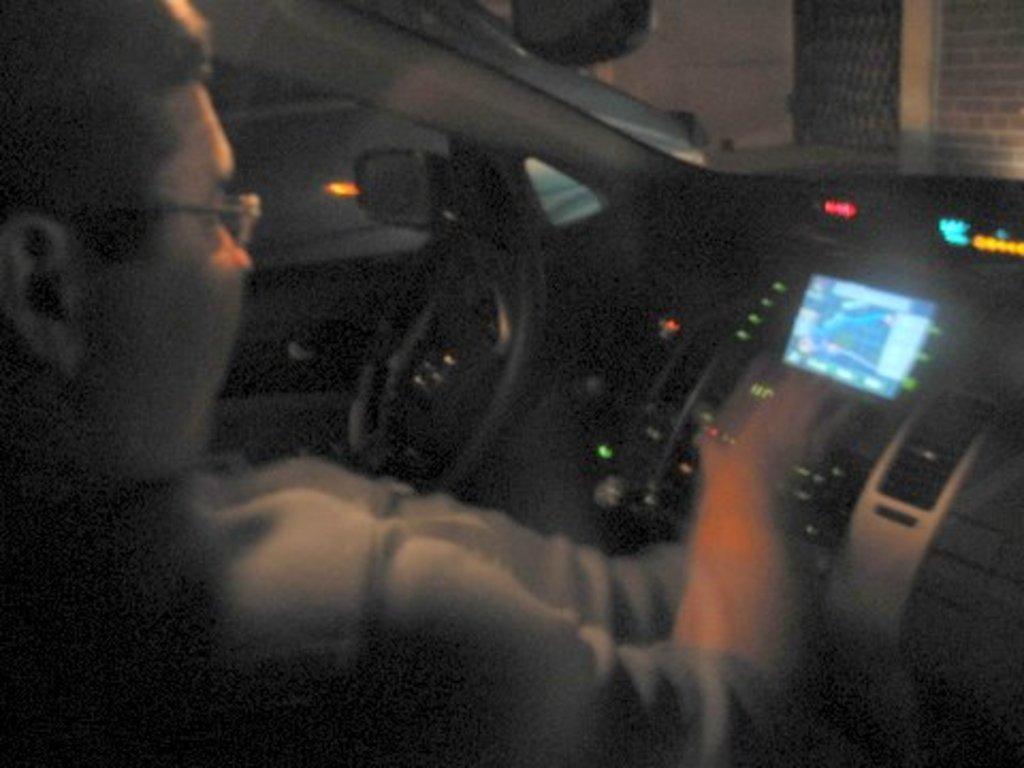Please provide a concise description of this image. In this picture, we can see a person in a car and we can see a building with some drills. 